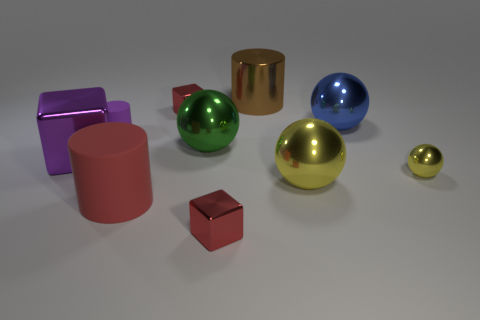Subtract 1 spheres. How many spheres are left? 3 Subtract all spheres. How many objects are left? 6 Add 5 small purple matte cylinders. How many small purple matte cylinders are left? 6 Add 3 large purple metal blocks. How many large purple metal blocks exist? 4 Subtract 0 brown blocks. How many objects are left? 10 Subtract all brown metal objects. Subtract all small yellow things. How many objects are left? 8 